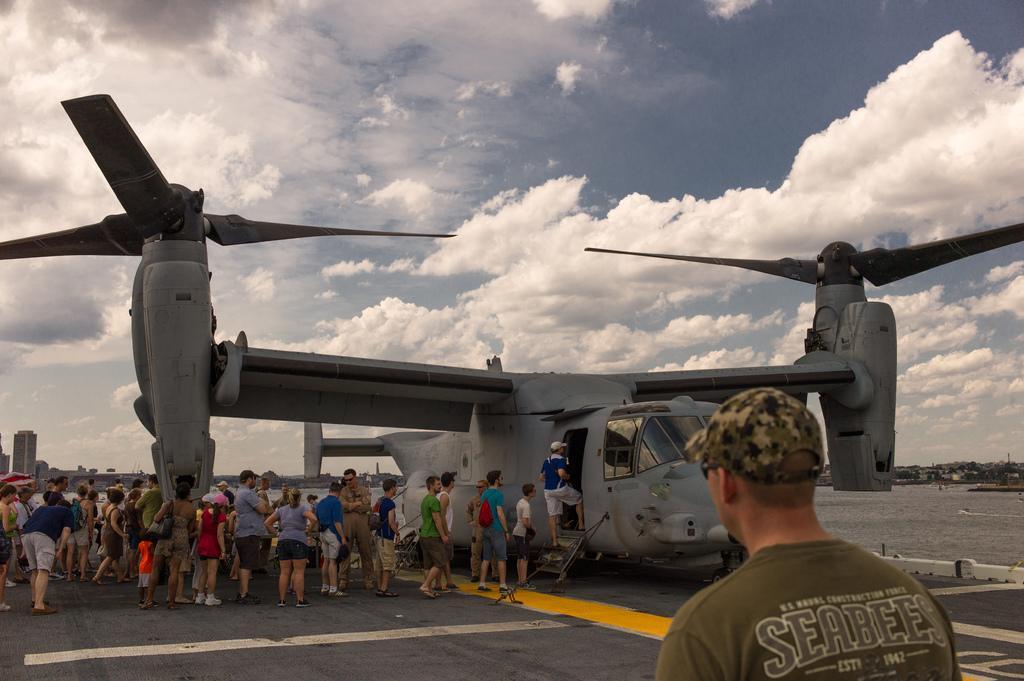How would you summarize this image in a sentence or two? In this image in the front there is a person wearing a brown colour shirt with some text written on it and in the center there are persons standing and walking and there is a Helicopter and there is a person climbing the steps of the helicopter and the sky is cloudy and in the background there are buildings. 